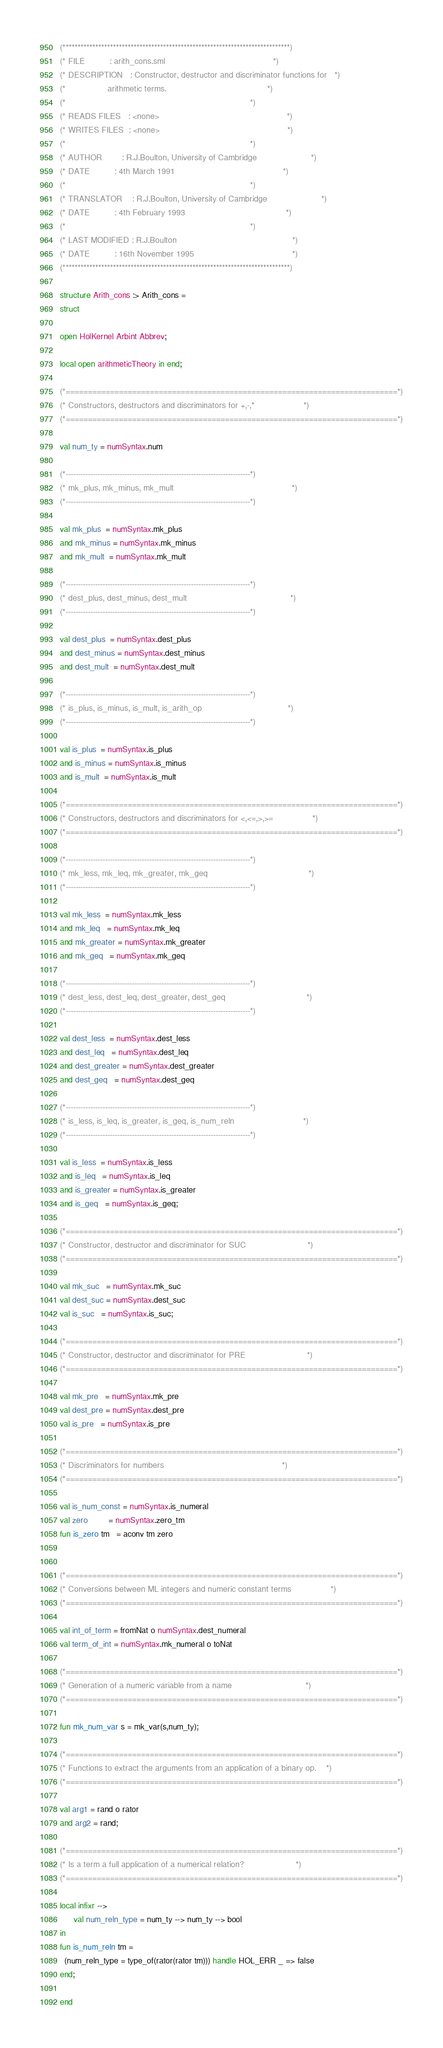Convert code to text. <code><loc_0><loc_0><loc_500><loc_500><_SML_>(*****************************************************************************)
(* FILE          : arith_cons.sml                                            *)
(* DESCRIPTION   : Constructor, destructor and discriminator functions for   *)
(*                 arithmetic terms.                                         *)
(*                                                                           *)
(* READS FILES   : <none>                                                    *)
(* WRITES FILES  : <none>                                                    *)
(*                                                                           *)
(* AUTHOR        : R.J.Boulton, University of Cambridge                      *)
(* DATE          : 4th March 1991                                            *)
(*                                                                           *)
(* TRANSLATOR    : R.J.Boulton, University of Cambridge                      *)
(* DATE          : 4th February 1993                                         *)
(*                                                                           *)
(* LAST MODIFIED : R.J.Boulton                                               *)
(* DATE          : 16th November 1995                                        *)
(*****************************************************************************)

structure Arith_cons :> Arith_cons =
struct

open HolKernel Arbint Abbrev;

local open arithmeticTheory in end;

(*===========================================================================*)
(* Constructors, destructors and discriminators for +,-,*                    *)
(*===========================================================================*)

val num_ty = numSyntax.num

(*---------------------------------------------------------------------------*)
(* mk_plus, mk_minus, mk_mult                                                *)
(*---------------------------------------------------------------------------*)

val mk_plus  = numSyntax.mk_plus
and mk_minus = numSyntax.mk_minus
and mk_mult  = numSyntax.mk_mult

(*---------------------------------------------------------------------------*)
(* dest_plus, dest_minus, dest_mult                                          *)
(*---------------------------------------------------------------------------*)

val dest_plus  = numSyntax.dest_plus
and dest_minus = numSyntax.dest_minus
and dest_mult  = numSyntax.dest_mult

(*---------------------------------------------------------------------------*)
(* is_plus, is_minus, is_mult, is_arith_op                                   *)
(*---------------------------------------------------------------------------*)

val is_plus  = numSyntax.is_plus
and is_minus = numSyntax.is_minus
and is_mult  = numSyntax.is_mult

(*===========================================================================*)
(* Constructors, destructors and discriminators for <,<=,>,>=                *)
(*===========================================================================*)

(*---------------------------------------------------------------------------*)
(* mk_less, mk_leq, mk_greater, mk_geq                                         *)
(*---------------------------------------------------------------------------*)

val mk_less  = numSyntax.mk_less
and mk_leq   = numSyntax.mk_leq
and mk_greater = numSyntax.mk_greater
and mk_geq   = numSyntax.mk_geq

(*---------------------------------------------------------------------------*)
(* dest_less, dest_leq, dest_greater, dest_geq                                 *)
(*---------------------------------------------------------------------------*)

val dest_less  = numSyntax.dest_less
and dest_leq   = numSyntax.dest_leq
and dest_greater = numSyntax.dest_greater
and dest_geq   = numSyntax.dest_geq

(*---------------------------------------------------------------------------*)
(* is_less, is_leq, is_greater, is_geq, is_num_reln                            *)
(*---------------------------------------------------------------------------*)

val is_less  = numSyntax.is_less
and is_leq   = numSyntax.is_leq
and is_greater = numSyntax.is_greater
and is_geq   = numSyntax.is_geq;

(*===========================================================================*)
(* Constructor, destructor and discriminator for SUC                         *)
(*===========================================================================*)

val mk_suc   = numSyntax.mk_suc
val dest_suc = numSyntax.dest_suc
val is_suc   = numSyntax.is_suc;

(*===========================================================================*)
(* Constructor, destructor and discriminator for PRE                         *)
(*===========================================================================*)

val mk_pre   = numSyntax.mk_pre
val dest_pre = numSyntax.dest_pre
val is_pre   = numSyntax.is_pre

(*===========================================================================*)
(* Discriminators for numbers                                                *)
(*===========================================================================*)

val is_num_const = numSyntax.is_numeral
val zero         = numSyntax.zero_tm
fun is_zero tm   = aconv tm zero


(*===========================================================================*)
(* Conversions between ML integers and numeric constant terms                *)
(*===========================================================================*)

val int_of_term = fromNat o numSyntax.dest_numeral
val term_of_int = numSyntax.mk_numeral o toNat

(*===========================================================================*)
(* Generation of a numeric variable from a name                              *)
(*===========================================================================*)

fun mk_num_var s = mk_var(s,num_ty);

(*===========================================================================*)
(* Functions to extract the arguments from an application of a binary op.    *)
(*===========================================================================*)

val arg1 = rand o rator
and arg2 = rand;

(*===========================================================================*)
(* Is a term a full application of a numerical relation?                     *)
(*===========================================================================*)

local infixr -->
      val num_reln_type = num_ty --> num_ty --> bool
in
fun is_num_reln tm =
  (num_reln_type = type_of(rator(rator tm))) handle HOL_ERR _ => false
end;

end
</code> 